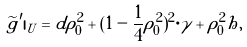<formula> <loc_0><loc_0><loc_500><loc_500>\widetilde { g } ^ { \prime } | _ { U } = d \rho _ { 0 } ^ { 2 } + ( 1 - \frac { 1 } { 4 } \rho _ { 0 } ^ { 2 } ) ^ { 2 } \cdot \gamma + \rho _ { 0 } ^ { 2 } h ,</formula> 